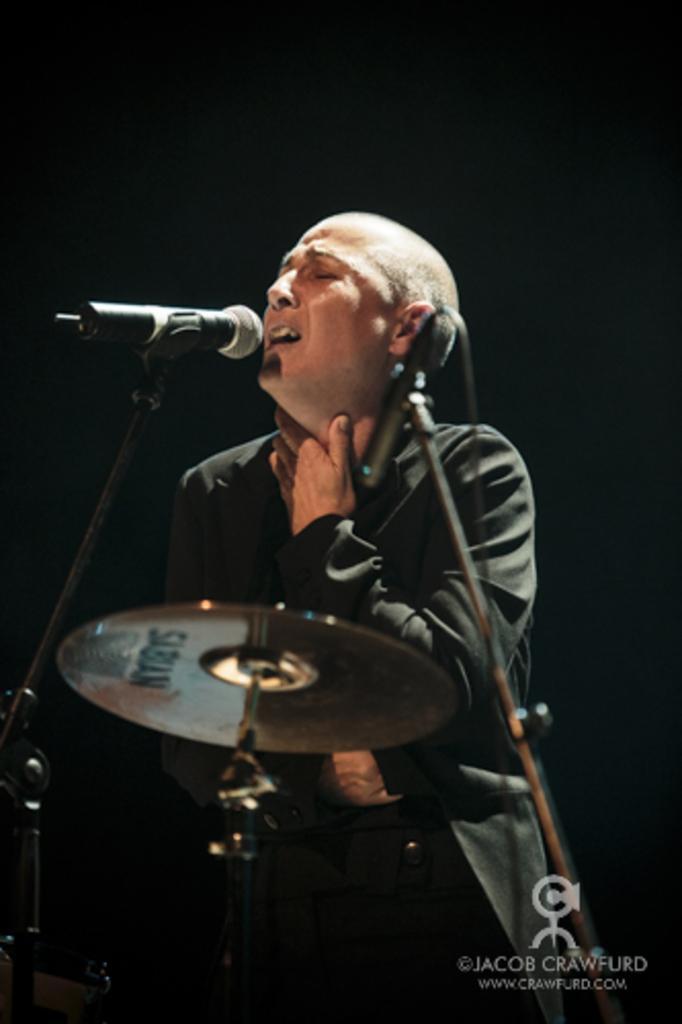How would you summarize this image in a sentence or two? In this image a person is singing wearing black dress. In front of her there are mice and drums. 